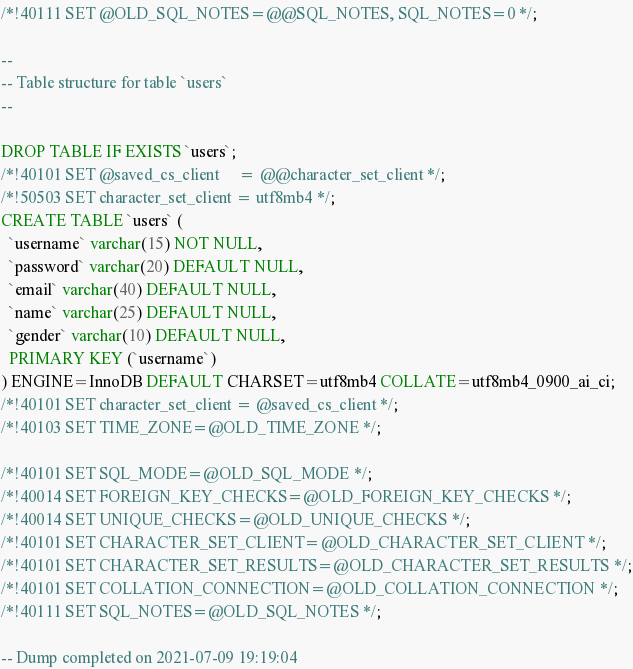<code> <loc_0><loc_0><loc_500><loc_500><_SQL_>/*!40111 SET @OLD_SQL_NOTES=@@SQL_NOTES, SQL_NOTES=0 */;

--
-- Table structure for table `users`
--

DROP TABLE IF EXISTS `users`;
/*!40101 SET @saved_cs_client     = @@character_set_client */;
/*!50503 SET character_set_client = utf8mb4 */;
CREATE TABLE `users` (
  `username` varchar(15) NOT NULL,
  `password` varchar(20) DEFAULT NULL,
  `email` varchar(40) DEFAULT NULL,
  `name` varchar(25) DEFAULT NULL,
  `gender` varchar(10) DEFAULT NULL,
  PRIMARY KEY (`username`)
) ENGINE=InnoDB DEFAULT CHARSET=utf8mb4 COLLATE=utf8mb4_0900_ai_ci;
/*!40101 SET character_set_client = @saved_cs_client */;
/*!40103 SET TIME_ZONE=@OLD_TIME_ZONE */;

/*!40101 SET SQL_MODE=@OLD_SQL_MODE */;
/*!40014 SET FOREIGN_KEY_CHECKS=@OLD_FOREIGN_KEY_CHECKS */;
/*!40014 SET UNIQUE_CHECKS=@OLD_UNIQUE_CHECKS */;
/*!40101 SET CHARACTER_SET_CLIENT=@OLD_CHARACTER_SET_CLIENT */;
/*!40101 SET CHARACTER_SET_RESULTS=@OLD_CHARACTER_SET_RESULTS */;
/*!40101 SET COLLATION_CONNECTION=@OLD_COLLATION_CONNECTION */;
/*!40111 SET SQL_NOTES=@OLD_SQL_NOTES */;

-- Dump completed on 2021-07-09 19:19:04
</code> 